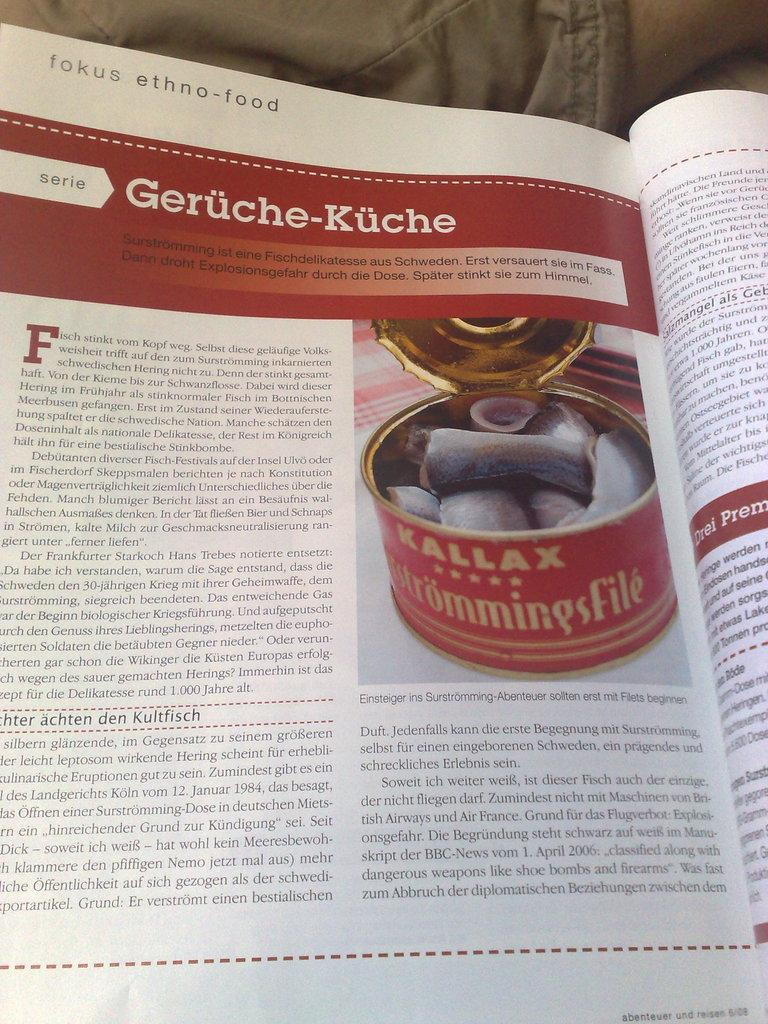<image>
Render a clear and concise summary of the photo. A magazine artlice talking about different ethnic foods. 